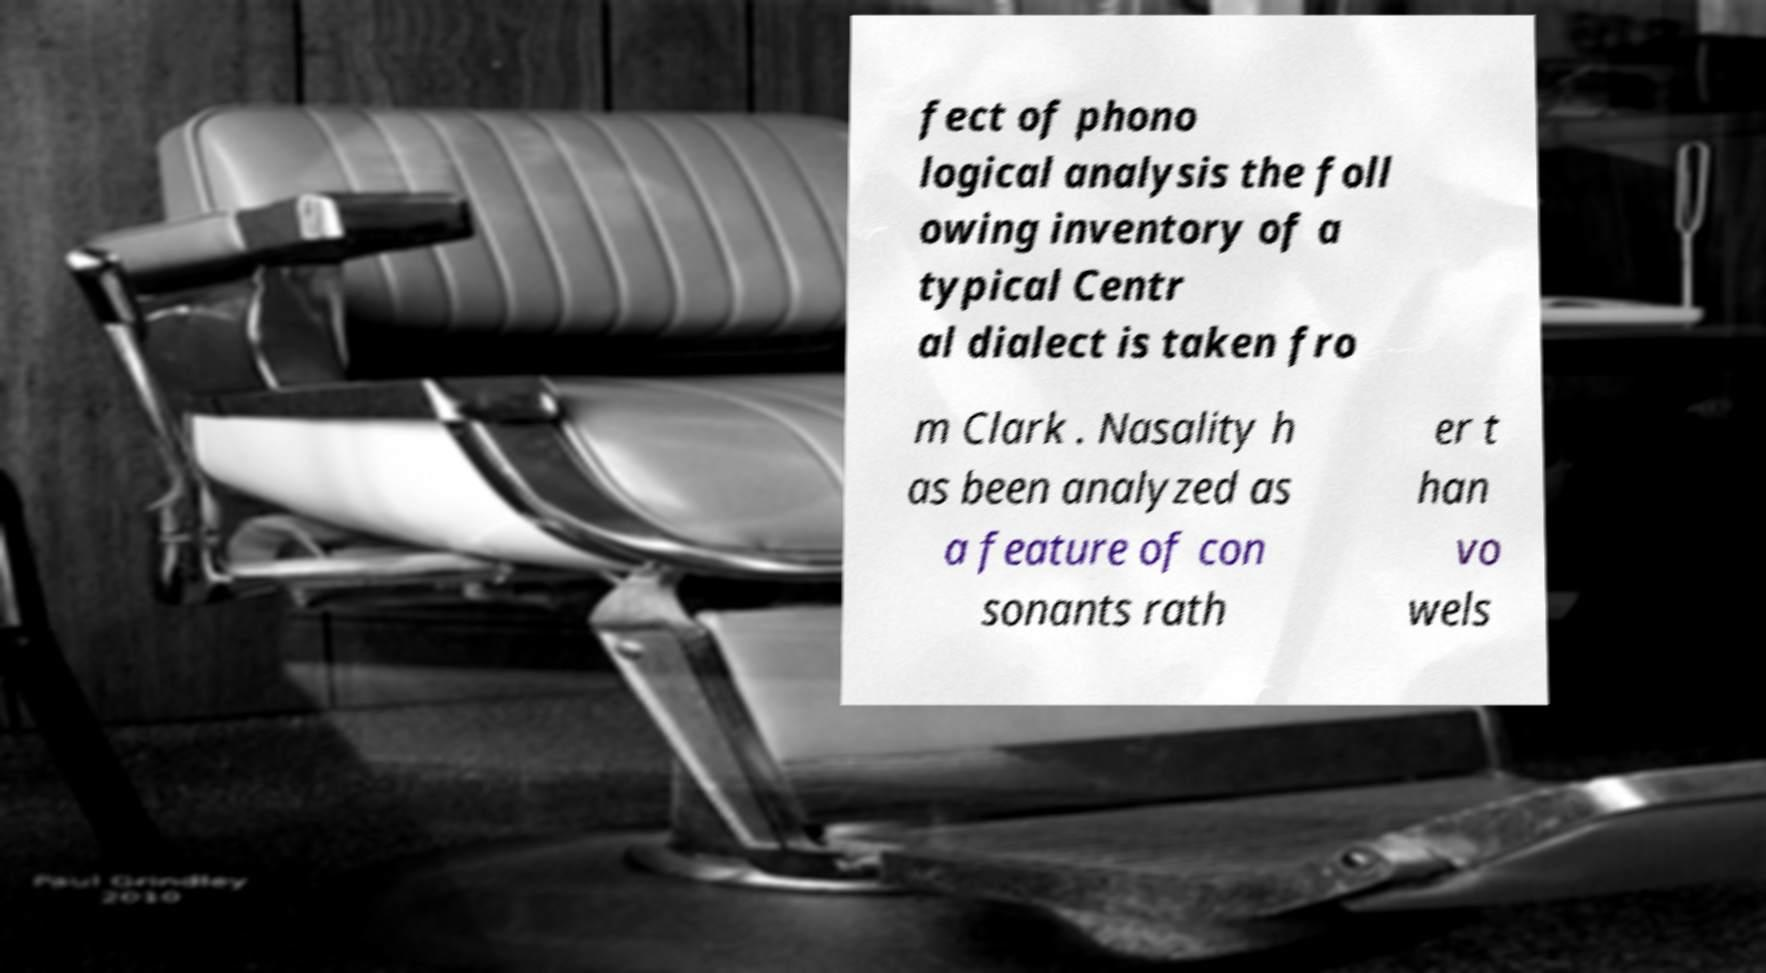Please read and relay the text visible in this image. What does it say? fect of phono logical analysis the foll owing inventory of a typical Centr al dialect is taken fro m Clark . Nasality h as been analyzed as a feature of con sonants rath er t han vo wels 